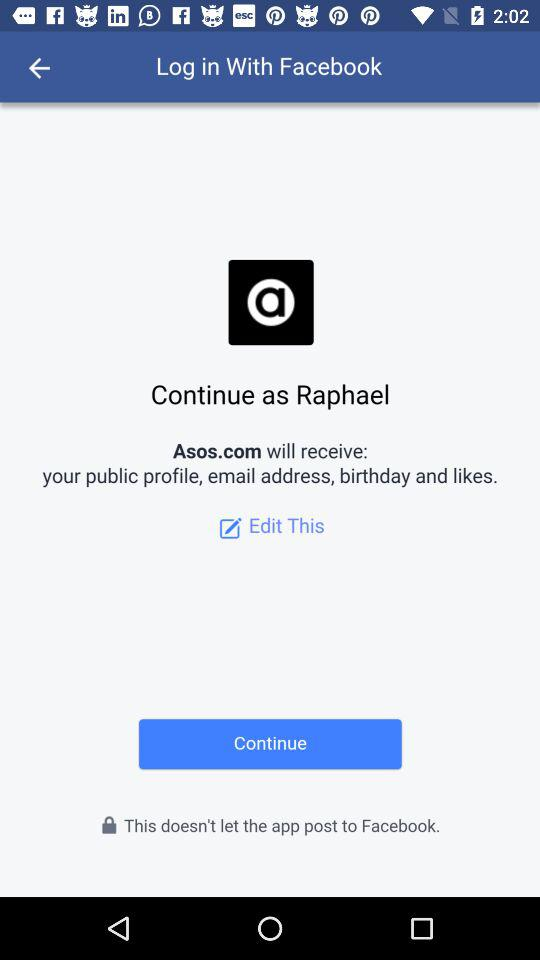What is the user's name? The user's name is Raphael. 